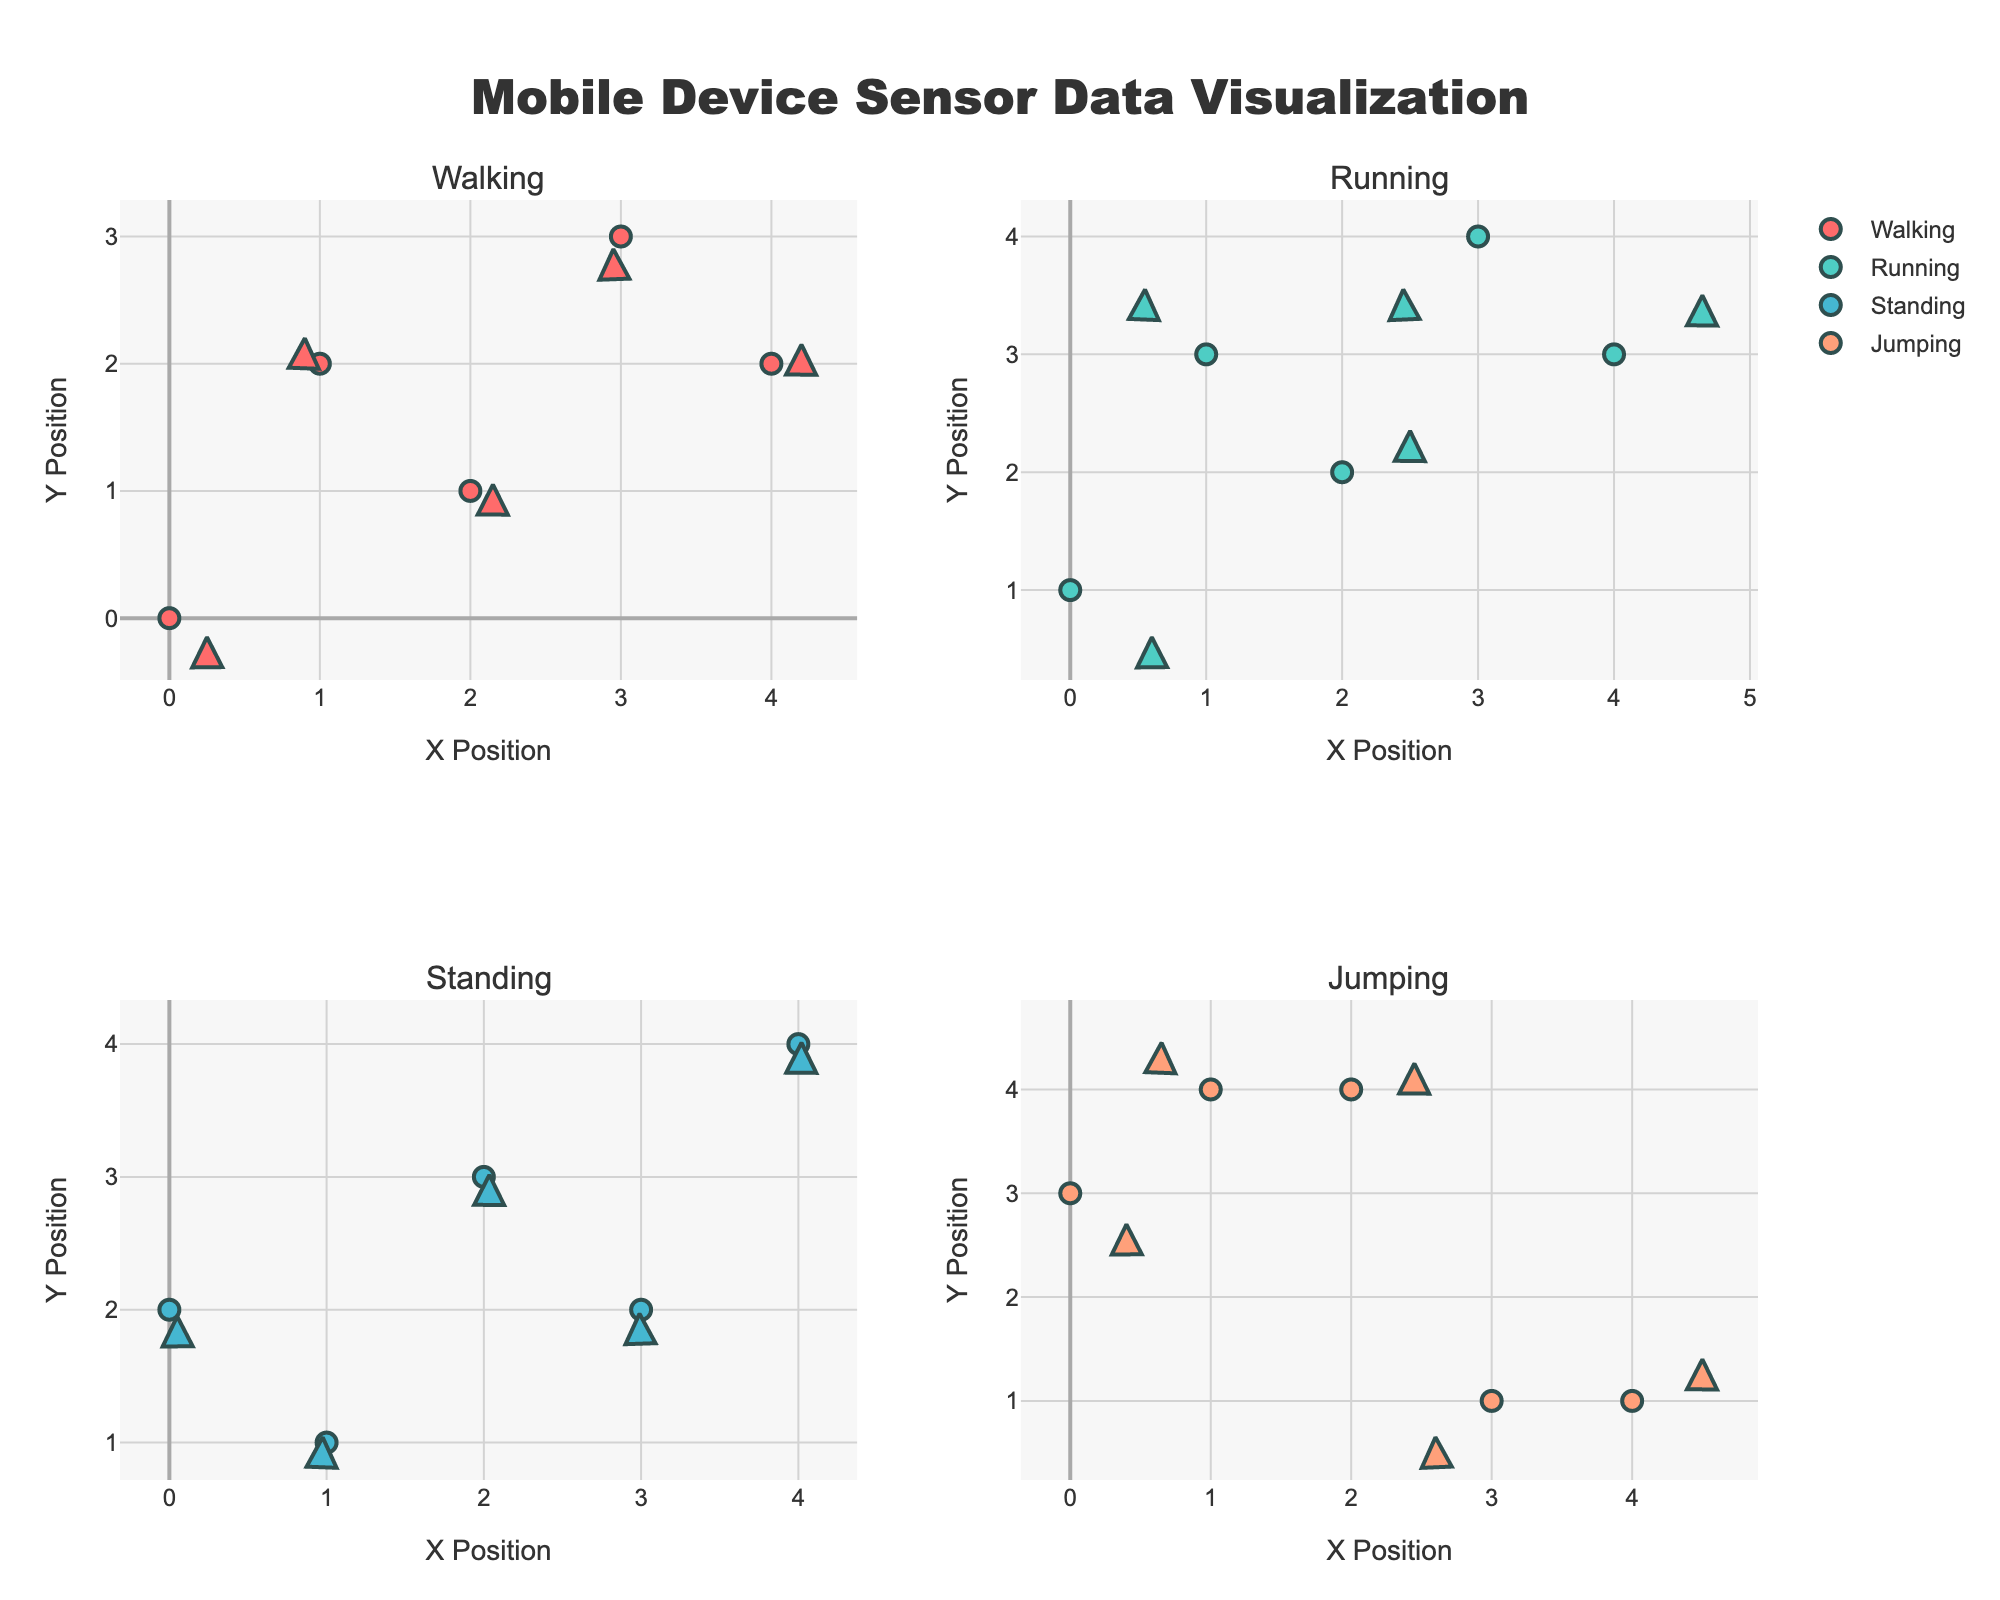What is the title of the plot? The title of the plot is typically placed at the top of the figure. For this plot, it is stated in the code provided in the "title" dictionary attribute.
Answer: Mobile Device Sensor Data Visualization How many activities are visualized in the plot? The code indicates that unique activity types are extracted using `df['activity'].unique()`, which results in four activities as shown in the subplot titles.
Answer: 4 Which colors are used to represent the different activities? The code specifies a custom color palette with four different colors assigned to the activities: Walking, Running, Standing, and Jumping. These colors are spread across the subplots.
Answer: Red, Turquoise, Light Blue, Light Salmon What information is displayed on the x-axis and y-axis in all subplots? The code setting `fig.update_xaxes(title_text="X Position")` and `fig.update_yaxes(title_text="Y Position")` indicates that both axes represent positional data in each subplot.
Answer: X Position (x-axis) and Y Position (y-axis) Which activity shows the most variation in vector directions? By observing the plotted vectors (arrows) in each subplot, the activity with the most varied directions of vectors can be determined. Running shows significant variability in vector orientations.
Answer: Running Compare the direction vectors of the "Walking" and "Standing" activities. Which activity has more consistent direction vectors? Comparing both subplots, in the "Standing" section the vectors are relatively consistent (milder variations), whereas in the "Walking" section they change directions more frequently.
Answer: Standing In which subplot do the vectors have the largest magnitudes? The size of the direction vectors can be assessed by the length of the arrows in each subplot. Running tends to have the longest vectors, indicating larger magnitudes.
Answer: Running What is inferred about user motion from the vectors in the "Jumping" activity? The arrows in the "Jumping" subplot mostly point diagonally with considerable lengths, indicating energetic oscillatory movements typical for jumping.
Answer: Energetic and varied motion How do the vector patterns help distinguish the "Walking" activity from the "Running" activity? The "Walking" subplot depicts smaller, less varied arrow lengths and directions turning gradually, whereas "Running" shows longer and widely varied arrows, reflecting more dynamic movement.
Answer: Walking: smaller, gradual changes; Running: larger, dynamic changes For which activity do the position markers (circles) appear most clustered? By inspecting the distribution of the markers (circles) for each activity, "Standing" shows the most clustered positional data, indicating limited movement.
Answer: Standing 